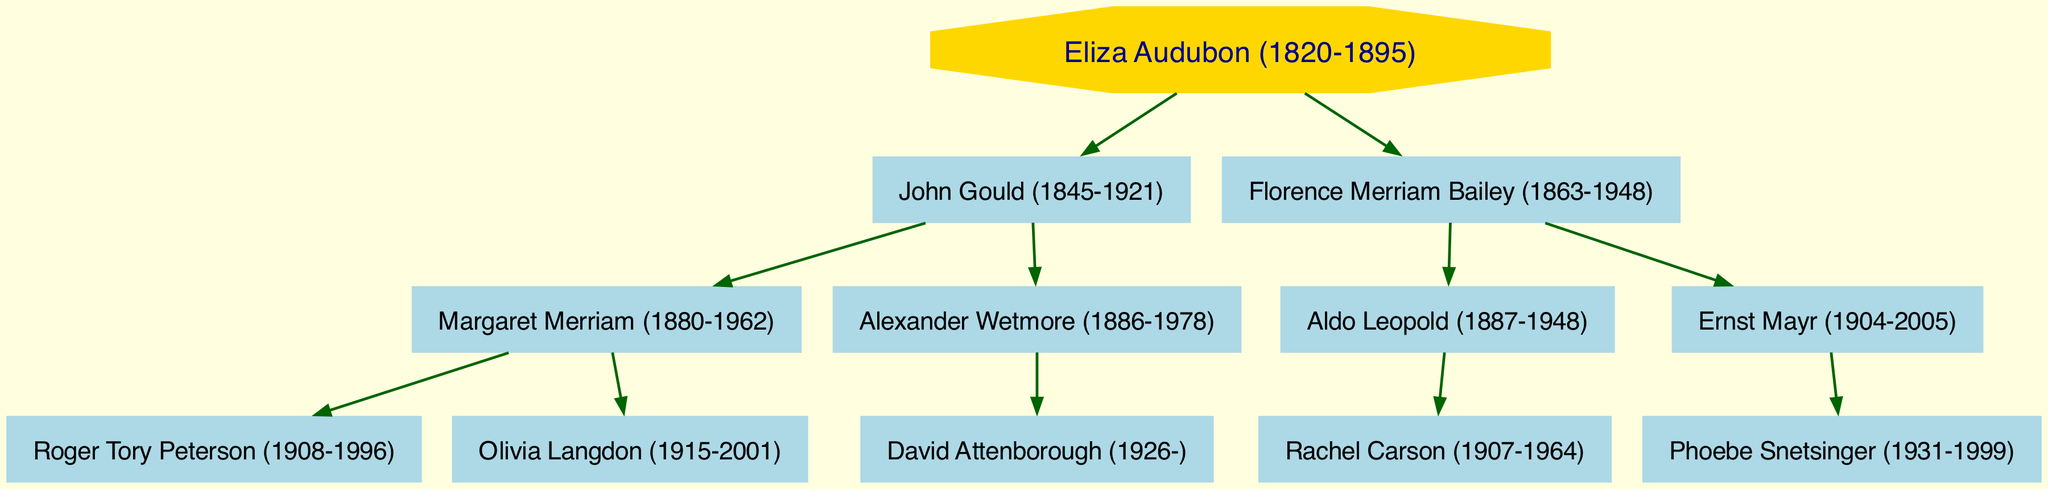What is the name of the root individual in the family tree? The family tree starts with the root individual identified as "Eliza Audubon (1820-1895)" at the top of the diagram.
Answer: Eliza Audubon (1820-1895) How many children does John Gould have? John Gould has two children as depicted in the diagram; they are "Margaret Merriam (1880-1962)" and "Alexander Wetmore (1886-1978)".
Answer: 2 Who is the child of Florence Merriam Bailey? In the diagram, Florence Merriam Bailey has two children: "Aldo Leopold (1887-1948)" and "Ernst Mayr (1904-2005)". The question specifies one child, so we can cite any one of them, such as "Aldo Leopold (1887-1948)".
Answer: Aldo Leopold (1887-1948) Which individual is the parent of Roger Tory Peterson? Looking at the diagram, Roger Tory Peterson is a child of "Margaret Merriam (1880-1962)", who is the daughter of John Gould. Therefore, Margaret is the parent of Roger.
Answer: Margaret Merriam (1880-1962) Who is the grandparent of David Attenborough? To find the grandparent of David Attenborough, we trace back to his parent, who is "Alexander Wetmore (1886-1978)", and then look at who is above Alexander in the family tree, which is "John Gould", thus John Gould is the grandparent of David Attenborough.
Answer: John Gould (1845-1921) What is the relationship between Rachel Carson and Aldo Leopold? Rachel Carson is the child of Aldo Leopold, as outlined in the diagram. They are in a direct parent-child relationship, with Aldo being her father.
Answer: Father-Daughter How many individuals are there in total in the family tree? By counting all entities represented in the diagram, including the root and all descendants, the total comes to ten: Eliza Audubon, John Gould, Florence Merriam Bailey, Margaret Merriam, Alexander Wetmore, Aldo Leopold, Ernst Mayr, Roger Tory Peterson, Olivia Langdon, and David Attenborough.
Answer: 10 What type of relationships does this diagram illustrate? This family tree specifically illustrates familial relationships, which include parent-child connections and generational lineage extending from a single root ancestor.
Answer: Familial Relationships Which individual in the diagram was born in 1863? Scanning through the birth years of the individuals in the diagram, "Florence Merriam Bailey" is identified as being born in the year 1863.
Answer: Florence Merriam Bailey 